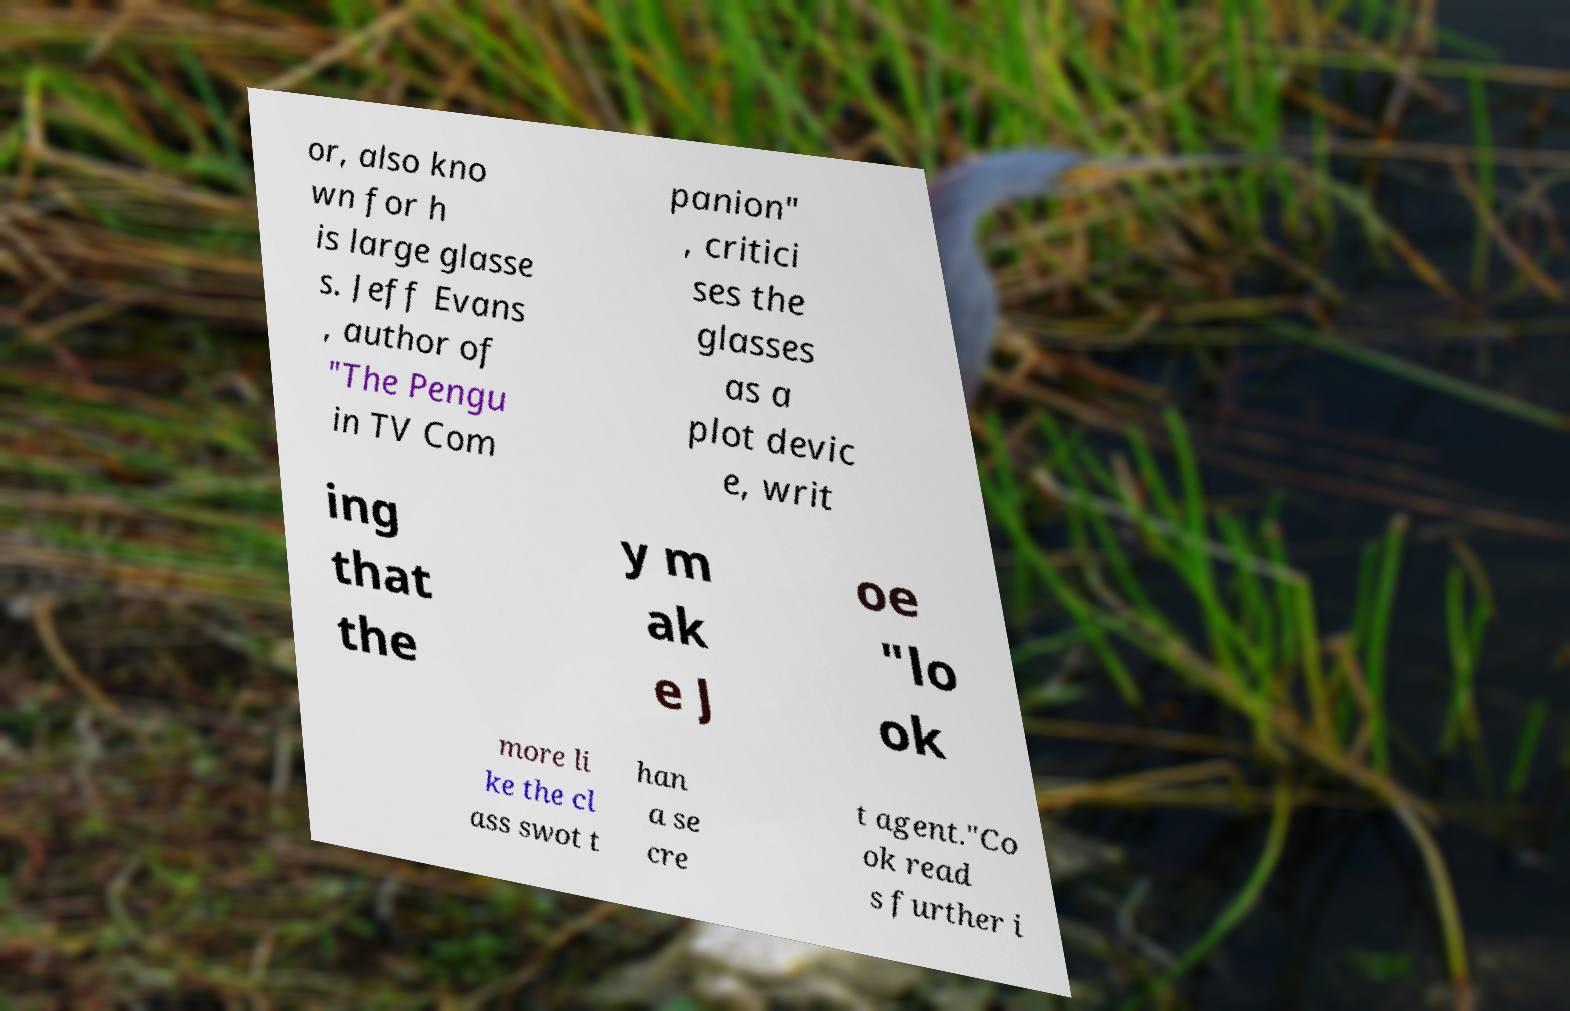For documentation purposes, I need the text within this image transcribed. Could you provide that? or, also kno wn for h is large glasse s. Jeff Evans , author of "The Pengu in TV Com panion" , critici ses the glasses as a plot devic e, writ ing that the y m ak e J oe "lo ok more li ke the cl ass swot t han a se cre t agent."Co ok read s further i 